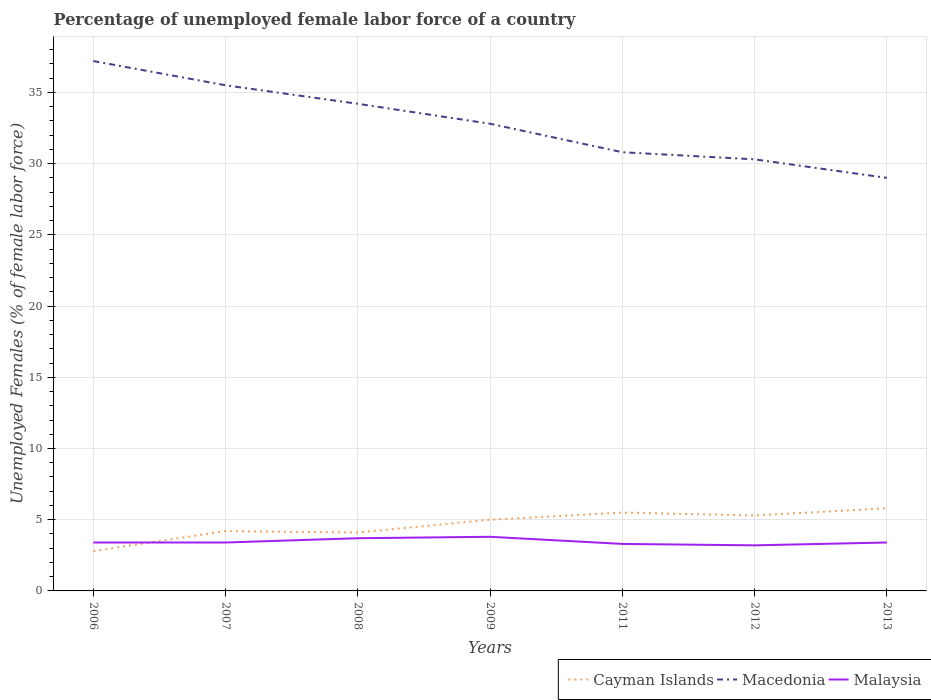How many different coloured lines are there?
Ensure brevity in your answer.  3. Is the number of lines equal to the number of legend labels?
Keep it short and to the point. Yes. Across all years, what is the maximum percentage of unemployed female labor force in Malaysia?
Provide a short and direct response. 3.2. What is the total percentage of unemployed female labor force in Malaysia in the graph?
Make the answer very short. 0.1. What is the difference between the highest and the second highest percentage of unemployed female labor force in Macedonia?
Provide a short and direct response. 8.2. Is the percentage of unemployed female labor force in Macedonia strictly greater than the percentage of unemployed female labor force in Cayman Islands over the years?
Offer a very short reply. No. What is the difference between two consecutive major ticks on the Y-axis?
Offer a very short reply. 5. Does the graph contain any zero values?
Make the answer very short. No. Where does the legend appear in the graph?
Offer a very short reply. Bottom right. How many legend labels are there?
Offer a very short reply. 3. What is the title of the graph?
Offer a terse response. Percentage of unemployed female labor force of a country. Does "Haiti" appear as one of the legend labels in the graph?
Make the answer very short. No. What is the label or title of the Y-axis?
Make the answer very short. Unemployed Females (% of female labor force). What is the Unemployed Females (% of female labor force) in Cayman Islands in 2006?
Ensure brevity in your answer.  2.8. What is the Unemployed Females (% of female labor force) of Macedonia in 2006?
Provide a succinct answer. 37.2. What is the Unemployed Females (% of female labor force) in Malaysia in 2006?
Offer a terse response. 3.4. What is the Unemployed Females (% of female labor force) of Cayman Islands in 2007?
Provide a succinct answer. 4.2. What is the Unemployed Females (% of female labor force) of Macedonia in 2007?
Provide a succinct answer. 35.5. What is the Unemployed Females (% of female labor force) in Malaysia in 2007?
Keep it short and to the point. 3.4. What is the Unemployed Females (% of female labor force) of Cayman Islands in 2008?
Keep it short and to the point. 4.1. What is the Unemployed Females (% of female labor force) of Macedonia in 2008?
Your response must be concise. 34.2. What is the Unemployed Females (% of female labor force) in Malaysia in 2008?
Make the answer very short. 3.7. What is the Unemployed Females (% of female labor force) in Cayman Islands in 2009?
Make the answer very short. 5. What is the Unemployed Females (% of female labor force) of Macedonia in 2009?
Provide a short and direct response. 32.8. What is the Unemployed Females (% of female labor force) of Malaysia in 2009?
Your answer should be compact. 3.8. What is the Unemployed Females (% of female labor force) of Cayman Islands in 2011?
Keep it short and to the point. 5.5. What is the Unemployed Females (% of female labor force) in Macedonia in 2011?
Your response must be concise. 30.8. What is the Unemployed Females (% of female labor force) of Malaysia in 2011?
Give a very brief answer. 3.3. What is the Unemployed Females (% of female labor force) of Cayman Islands in 2012?
Your answer should be compact. 5.3. What is the Unemployed Females (% of female labor force) of Macedonia in 2012?
Provide a succinct answer. 30.3. What is the Unemployed Females (% of female labor force) of Malaysia in 2012?
Keep it short and to the point. 3.2. What is the Unemployed Females (% of female labor force) of Cayman Islands in 2013?
Provide a succinct answer. 5.8. What is the Unemployed Females (% of female labor force) of Malaysia in 2013?
Make the answer very short. 3.4. Across all years, what is the maximum Unemployed Females (% of female labor force) of Cayman Islands?
Ensure brevity in your answer.  5.8. Across all years, what is the maximum Unemployed Females (% of female labor force) in Macedonia?
Your response must be concise. 37.2. Across all years, what is the maximum Unemployed Females (% of female labor force) in Malaysia?
Offer a terse response. 3.8. Across all years, what is the minimum Unemployed Females (% of female labor force) in Cayman Islands?
Your answer should be compact. 2.8. Across all years, what is the minimum Unemployed Females (% of female labor force) of Malaysia?
Your response must be concise. 3.2. What is the total Unemployed Females (% of female labor force) in Cayman Islands in the graph?
Keep it short and to the point. 32.7. What is the total Unemployed Females (% of female labor force) in Macedonia in the graph?
Provide a short and direct response. 229.8. What is the total Unemployed Females (% of female labor force) in Malaysia in the graph?
Keep it short and to the point. 24.2. What is the difference between the Unemployed Females (% of female labor force) in Malaysia in 2006 and that in 2007?
Ensure brevity in your answer.  0. What is the difference between the Unemployed Females (% of female labor force) of Macedonia in 2006 and that in 2008?
Your answer should be very brief. 3. What is the difference between the Unemployed Females (% of female labor force) of Macedonia in 2006 and that in 2011?
Your answer should be very brief. 6.4. What is the difference between the Unemployed Females (% of female labor force) of Cayman Islands in 2006 and that in 2012?
Ensure brevity in your answer.  -2.5. What is the difference between the Unemployed Females (% of female labor force) in Malaysia in 2006 and that in 2012?
Give a very brief answer. 0.2. What is the difference between the Unemployed Females (% of female labor force) of Cayman Islands in 2006 and that in 2013?
Make the answer very short. -3. What is the difference between the Unemployed Females (% of female labor force) of Malaysia in 2006 and that in 2013?
Your answer should be very brief. 0. What is the difference between the Unemployed Females (% of female labor force) of Macedonia in 2007 and that in 2008?
Ensure brevity in your answer.  1.3. What is the difference between the Unemployed Females (% of female labor force) in Malaysia in 2007 and that in 2008?
Your response must be concise. -0.3. What is the difference between the Unemployed Females (% of female labor force) in Malaysia in 2007 and that in 2011?
Offer a terse response. 0.1. What is the difference between the Unemployed Females (% of female labor force) in Macedonia in 2007 and that in 2012?
Your answer should be very brief. 5.2. What is the difference between the Unemployed Females (% of female labor force) in Malaysia in 2007 and that in 2012?
Make the answer very short. 0.2. What is the difference between the Unemployed Females (% of female labor force) in Macedonia in 2007 and that in 2013?
Your answer should be very brief. 6.5. What is the difference between the Unemployed Females (% of female labor force) of Malaysia in 2007 and that in 2013?
Provide a short and direct response. 0. What is the difference between the Unemployed Females (% of female labor force) of Malaysia in 2008 and that in 2009?
Give a very brief answer. -0.1. What is the difference between the Unemployed Females (% of female labor force) of Malaysia in 2008 and that in 2011?
Your answer should be very brief. 0.4. What is the difference between the Unemployed Females (% of female labor force) of Cayman Islands in 2008 and that in 2012?
Ensure brevity in your answer.  -1.2. What is the difference between the Unemployed Females (% of female labor force) in Malaysia in 2008 and that in 2012?
Provide a succinct answer. 0.5. What is the difference between the Unemployed Females (% of female labor force) in Macedonia in 2008 and that in 2013?
Make the answer very short. 5.2. What is the difference between the Unemployed Females (% of female labor force) in Cayman Islands in 2009 and that in 2011?
Offer a terse response. -0.5. What is the difference between the Unemployed Females (% of female labor force) of Malaysia in 2009 and that in 2011?
Provide a short and direct response. 0.5. What is the difference between the Unemployed Females (% of female labor force) in Macedonia in 2009 and that in 2012?
Make the answer very short. 2.5. What is the difference between the Unemployed Females (% of female labor force) of Malaysia in 2009 and that in 2013?
Provide a short and direct response. 0.4. What is the difference between the Unemployed Females (% of female labor force) of Malaysia in 2011 and that in 2012?
Your answer should be compact. 0.1. What is the difference between the Unemployed Females (% of female labor force) of Cayman Islands in 2011 and that in 2013?
Give a very brief answer. -0.3. What is the difference between the Unemployed Females (% of female labor force) of Macedonia in 2012 and that in 2013?
Provide a short and direct response. 1.3. What is the difference between the Unemployed Females (% of female labor force) of Malaysia in 2012 and that in 2013?
Offer a very short reply. -0.2. What is the difference between the Unemployed Females (% of female labor force) in Cayman Islands in 2006 and the Unemployed Females (% of female labor force) in Macedonia in 2007?
Provide a succinct answer. -32.7. What is the difference between the Unemployed Females (% of female labor force) in Macedonia in 2006 and the Unemployed Females (% of female labor force) in Malaysia in 2007?
Keep it short and to the point. 33.8. What is the difference between the Unemployed Females (% of female labor force) in Cayman Islands in 2006 and the Unemployed Females (% of female labor force) in Macedonia in 2008?
Offer a terse response. -31.4. What is the difference between the Unemployed Females (% of female labor force) in Macedonia in 2006 and the Unemployed Females (% of female labor force) in Malaysia in 2008?
Your answer should be very brief. 33.5. What is the difference between the Unemployed Females (% of female labor force) in Macedonia in 2006 and the Unemployed Females (% of female labor force) in Malaysia in 2009?
Your answer should be compact. 33.4. What is the difference between the Unemployed Females (% of female labor force) of Cayman Islands in 2006 and the Unemployed Females (% of female labor force) of Macedonia in 2011?
Offer a very short reply. -28. What is the difference between the Unemployed Females (% of female labor force) in Cayman Islands in 2006 and the Unemployed Females (% of female labor force) in Malaysia in 2011?
Offer a terse response. -0.5. What is the difference between the Unemployed Females (% of female labor force) of Macedonia in 2006 and the Unemployed Females (% of female labor force) of Malaysia in 2011?
Your response must be concise. 33.9. What is the difference between the Unemployed Females (% of female labor force) of Cayman Islands in 2006 and the Unemployed Females (% of female labor force) of Macedonia in 2012?
Your response must be concise. -27.5. What is the difference between the Unemployed Females (% of female labor force) of Cayman Islands in 2006 and the Unemployed Females (% of female labor force) of Malaysia in 2012?
Give a very brief answer. -0.4. What is the difference between the Unemployed Females (% of female labor force) in Macedonia in 2006 and the Unemployed Females (% of female labor force) in Malaysia in 2012?
Offer a terse response. 34. What is the difference between the Unemployed Females (% of female labor force) in Cayman Islands in 2006 and the Unemployed Females (% of female labor force) in Macedonia in 2013?
Give a very brief answer. -26.2. What is the difference between the Unemployed Females (% of female labor force) of Macedonia in 2006 and the Unemployed Females (% of female labor force) of Malaysia in 2013?
Your answer should be compact. 33.8. What is the difference between the Unemployed Females (% of female labor force) of Cayman Islands in 2007 and the Unemployed Females (% of female labor force) of Malaysia in 2008?
Offer a terse response. 0.5. What is the difference between the Unemployed Females (% of female labor force) of Macedonia in 2007 and the Unemployed Females (% of female labor force) of Malaysia in 2008?
Your answer should be compact. 31.8. What is the difference between the Unemployed Females (% of female labor force) of Cayman Islands in 2007 and the Unemployed Females (% of female labor force) of Macedonia in 2009?
Provide a succinct answer. -28.6. What is the difference between the Unemployed Females (% of female labor force) of Macedonia in 2007 and the Unemployed Females (% of female labor force) of Malaysia in 2009?
Make the answer very short. 31.7. What is the difference between the Unemployed Females (% of female labor force) of Cayman Islands in 2007 and the Unemployed Females (% of female labor force) of Macedonia in 2011?
Give a very brief answer. -26.6. What is the difference between the Unemployed Females (% of female labor force) in Macedonia in 2007 and the Unemployed Females (% of female labor force) in Malaysia in 2011?
Your answer should be compact. 32.2. What is the difference between the Unemployed Females (% of female labor force) of Cayman Islands in 2007 and the Unemployed Females (% of female labor force) of Macedonia in 2012?
Make the answer very short. -26.1. What is the difference between the Unemployed Females (% of female labor force) in Cayman Islands in 2007 and the Unemployed Females (% of female labor force) in Malaysia in 2012?
Provide a succinct answer. 1. What is the difference between the Unemployed Females (% of female labor force) in Macedonia in 2007 and the Unemployed Females (% of female labor force) in Malaysia in 2012?
Give a very brief answer. 32.3. What is the difference between the Unemployed Females (% of female labor force) of Cayman Islands in 2007 and the Unemployed Females (% of female labor force) of Macedonia in 2013?
Your answer should be very brief. -24.8. What is the difference between the Unemployed Females (% of female labor force) in Cayman Islands in 2007 and the Unemployed Females (% of female labor force) in Malaysia in 2013?
Give a very brief answer. 0.8. What is the difference between the Unemployed Females (% of female labor force) of Macedonia in 2007 and the Unemployed Females (% of female labor force) of Malaysia in 2013?
Offer a very short reply. 32.1. What is the difference between the Unemployed Females (% of female labor force) in Cayman Islands in 2008 and the Unemployed Females (% of female labor force) in Macedonia in 2009?
Provide a succinct answer. -28.7. What is the difference between the Unemployed Females (% of female labor force) of Cayman Islands in 2008 and the Unemployed Females (% of female labor force) of Malaysia in 2009?
Keep it short and to the point. 0.3. What is the difference between the Unemployed Females (% of female labor force) in Macedonia in 2008 and the Unemployed Females (% of female labor force) in Malaysia in 2009?
Keep it short and to the point. 30.4. What is the difference between the Unemployed Females (% of female labor force) in Cayman Islands in 2008 and the Unemployed Females (% of female labor force) in Macedonia in 2011?
Make the answer very short. -26.7. What is the difference between the Unemployed Females (% of female labor force) in Macedonia in 2008 and the Unemployed Females (% of female labor force) in Malaysia in 2011?
Provide a succinct answer. 30.9. What is the difference between the Unemployed Females (% of female labor force) in Cayman Islands in 2008 and the Unemployed Females (% of female labor force) in Macedonia in 2012?
Your answer should be compact. -26.2. What is the difference between the Unemployed Females (% of female labor force) in Cayman Islands in 2008 and the Unemployed Females (% of female labor force) in Malaysia in 2012?
Provide a succinct answer. 0.9. What is the difference between the Unemployed Females (% of female labor force) of Cayman Islands in 2008 and the Unemployed Females (% of female labor force) of Macedonia in 2013?
Your answer should be compact. -24.9. What is the difference between the Unemployed Females (% of female labor force) in Macedonia in 2008 and the Unemployed Females (% of female labor force) in Malaysia in 2013?
Provide a short and direct response. 30.8. What is the difference between the Unemployed Females (% of female labor force) in Cayman Islands in 2009 and the Unemployed Females (% of female labor force) in Macedonia in 2011?
Offer a terse response. -25.8. What is the difference between the Unemployed Females (% of female labor force) in Cayman Islands in 2009 and the Unemployed Females (% of female labor force) in Malaysia in 2011?
Offer a terse response. 1.7. What is the difference between the Unemployed Females (% of female labor force) of Macedonia in 2009 and the Unemployed Females (% of female labor force) of Malaysia in 2011?
Ensure brevity in your answer.  29.5. What is the difference between the Unemployed Females (% of female labor force) of Cayman Islands in 2009 and the Unemployed Females (% of female labor force) of Macedonia in 2012?
Offer a very short reply. -25.3. What is the difference between the Unemployed Females (% of female labor force) in Macedonia in 2009 and the Unemployed Females (% of female labor force) in Malaysia in 2012?
Offer a very short reply. 29.6. What is the difference between the Unemployed Females (% of female labor force) in Cayman Islands in 2009 and the Unemployed Females (% of female labor force) in Macedonia in 2013?
Your response must be concise. -24. What is the difference between the Unemployed Females (% of female labor force) in Macedonia in 2009 and the Unemployed Females (% of female labor force) in Malaysia in 2013?
Keep it short and to the point. 29.4. What is the difference between the Unemployed Females (% of female labor force) in Cayman Islands in 2011 and the Unemployed Females (% of female labor force) in Macedonia in 2012?
Offer a terse response. -24.8. What is the difference between the Unemployed Females (% of female labor force) in Macedonia in 2011 and the Unemployed Females (% of female labor force) in Malaysia in 2012?
Give a very brief answer. 27.6. What is the difference between the Unemployed Females (% of female labor force) of Cayman Islands in 2011 and the Unemployed Females (% of female labor force) of Macedonia in 2013?
Make the answer very short. -23.5. What is the difference between the Unemployed Females (% of female labor force) of Macedonia in 2011 and the Unemployed Females (% of female labor force) of Malaysia in 2013?
Provide a short and direct response. 27.4. What is the difference between the Unemployed Females (% of female labor force) in Cayman Islands in 2012 and the Unemployed Females (% of female labor force) in Macedonia in 2013?
Keep it short and to the point. -23.7. What is the difference between the Unemployed Females (% of female labor force) in Cayman Islands in 2012 and the Unemployed Females (% of female labor force) in Malaysia in 2013?
Ensure brevity in your answer.  1.9. What is the difference between the Unemployed Females (% of female labor force) in Macedonia in 2012 and the Unemployed Females (% of female labor force) in Malaysia in 2013?
Make the answer very short. 26.9. What is the average Unemployed Females (% of female labor force) in Cayman Islands per year?
Provide a short and direct response. 4.67. What is the average Unemployed Females (% of female labor force) of Macedonia per year?
Offer a terse response. 32.83. What is the average Unemployed Females (% of female labor force) in Malaysia per year?
Keep it short and to the point. 3.46. In the year 2006, what is the difference between the Unemployed Females (% of female labor force) of Cayman Islands and Unemployed Females (% of female labor force) of Macedonia?
Your answer should be very brief. -34.4. In the year 2006, what is the difference between the Unemployed Females (% of female labor force) in Macedonia and Unemployed Females (% of female labor force) in Malaysia?
Your answer should be compact. 33.8. In the year 2007, what is the difference between the Unemployed Females (% of female labor force) of Cayman Islands and Unemployed Females (% of female labor force) of Macedonia?
Your response must be concise. -31.3. In the year 2007, what is the difference between the Unemployed Females (% of female labor force) of Macedonia and Unemployed Females (% of female labor force) of Malaysia?
Offer a terse response. 32.1. In the year 2008, what is the difference between the Unemployed Females (% of female labor force) of Cayman Islands and Unemployed Females (% of female labor force) of Macedonia?
Provide a succinct answer. -30.1. In the year 2008, what is the difference between the Unemployed Females (% of female labor force) in Macedonia and Unemployed Females (% of female labor force) in Malaysia?
Your response must be concise. 30.5. In the year 2009, what is the difference between the Unemployed Females (% of female labor force) of Cayman Islands and Unemployed Females (% of female labor force) of Macedonia?
Provide a succinct answer. -27.8. In the year 2009, what is the difference between the Unemployed Females (% of female labor force) in Macedonia and Unemployed Females (% of female labor force) in Malaysia?
Provide a short and direct response. 29. In the year 2011, what is the difference between the Unemployed Females (% of female labor force) of Cayman Islands and Unemployed Females (% of female labor force) of Macedonia?
Ensure brevity in your answer.  -25.3. In the year 2011, what is the difference between the Unemployed Females (% of female labor force) in Cayman Islands and Unemployed Females (% of female labor force) in Malaysia?
Offer a very short reply. 2.2. In the year 2011, what is the difference between the Unemployed Females (% of female labor force) of Macedonia and Unemployed Females (% of female labor force) of Malaysia?
Give a very brief answer. 27.5. In the year 2012, what is the difference between the Unemployed Females (% of female labor force) of Cayman Islands and Unemployed Females (% of female labor force) of Macedonia?
Offer a terse response. -25. In the year 2012, what is the difference between the Unemployed Females (% of female labor force) of Cayman Islands and Unemployed Females (% of female labor force) of Malaysia?
Your response must be concise. 2.1. In the year 2012, what is the difference between the Unemployed Females (% of female labor force) in Macedonia and Unemployed Females (% of female labor force) in Malaysia?
Provide a short and direct response. 27.1. In the year 2013, what is the difference between the Unemployed Females (% of female labor force) in Cayman Islands and Unemployed Females (% of female labor force) in Macedonia?
Offer a terse response. -23.2. In the year 2013, what is the difference between the Unemployed Females (% of female labor force) of Cayman Islands and Unemployed Females (% of female labor force) of Malaysia?
Make the answer very short. 2.4. In the year 2013, what is the difference between the Unemployed Females (% of female labor force) of Macedonia and Unemployed Females (% of female labor force) of Malaysia?
Provide a succinct answer. 25.6. What is the ratio of the Unemployed Females (% of female labor force) of Cayman Islands in 2006 to that in 2007?
Your response must be concise. 0.67. What is the ratio of the Unemployed Females (% of female labor force) of Macedonia in 2006 to that in 2007?
Give a very brief answer. 1.05. What is the ratio of the Unemployed Females (% of female labor force) of Cayman Islands in 2006 to that in 2008?
Ensure brevity in your answer.  0.68. What is the ratio of the Unemployed Females (% of female labor force) in Macedonia in 2006 to that in 2008?
Make the answer very short. 1.09. What is the ratio of the Unemployed Females (% of female labor force) of Malaysia in 2006 to that in 2008?
Your answer should be very brief. 0.92. What is the ratio of the Unemployed Females (% of female labor force) of Cayman Islands in 2006 to that in 2009?
Your answer should be compact. 0.56. What is the ratio of the Unemployed Females (% of female labor force) in Macedonia in 2006 to that in 2009?
Keep it short and to the point. 1.13. What is the ratio of the Unemployed Females (% of female labor force) in Malaysia in 2006 to that in 2009?
Your answer should be very brief. 0.89. What is the ratio of the Unemployed Females (% of female labor force) of Cayman Islands in 2006 to that in 2011?
Offer a terse response. 0.51. What is the ratio of the Unemployed Females (% of female labor force) in Macedonia in 2006 to that in 2011?
Ensure brevity in your answer.  1.21. What is the ratio of the Unemployed Females (% of female labor force) of Malaysia in 2006 to that in 2011?
Offer a terse response. 1.03. What is the ratio of the Unemployed Females (% of female labor force) of Cayman Islands in 2006 to that in 2012?
Keep it short and to the point. 0.53. What is the ratio of the Unemployed Females (% of female labor force) of Macedonia in 2006 to that in 2012?
Make the answer very short. 1.23. What is the ratio of the Unemployed Females (% of female labor force) in Malaysia in 2006 to that in 2012?
Offer a very short reply. 1.06. What is the ratio of the Unemployed Females (% of female labor force) of Cayman Islands in 2006 to that in 2013?
Ensure brevity in your answer.  0.48. What is the ratio of the Unemployed Females (% of female labor force) of Macedonia in 2006 to that in 2013?
Provide a short and direct response. 1.28. What is the ratio of the Unemployed Females (% of female labor force) in Cayman Islands in 2007 to that in 2008?
Provide a succinct answer. 1.02. What is the ratio of the Unemployed Females (% of female labor force) in Macedonia in 2007 to that in 2008?
Provide a short and direct response. 1.04. What is the ratio of the Unemployed Females (% of female labor force) in Malaysia in 2007 to that in 2008?
Make the answer very short. 0.92. What is the ratio of the Unemployed Females (% of female labor force) in Cayman Islands in 2007 to that in 2009?
Your answer should be compact. 0.84. What is the ratio of the Unemployed Females (% of female labor force) in Macedonia in 2007 to that in 2009?
Ensure brevity in your answer.  1.08. What is the ratio of the Unemployed Females (% of female labor force) of Malaysia in 2007 to that in 2009?
Provide a short and direct response. 0.89. What is the ratio of the Unemployed Females (% of female labor force) in Cayman Islands in 2007 to that in 2011?
Keep it short and to the point. 0.76. What is the ratio of the Unemployed Females (% of female labor force) in Macedonia in 2007 to that in 2011?
Provide a short and direct response. 1.15. What is the ratio of the Unemployed Females (% of female labor force) of Malaysia in 2007 to that in 2011?
Your answer should be very brief. 1.03. What is the ratio of the Unemployed Females (% of female labor force) in Cayman Islands in 2007 to that in 2012?
Offer a terse response. 0.79. What is the ratio of the Unemployed Females (% of female labor force) of Macedonia in 2007 to that in 2012?
Give a very brief answer. 1.17. What is the ratio of the Unemployed Females (% of female labor force) of Cayman Islands in 2007 to that in 2013?
Your answer should be very brief. 0.72. What is the ratio of the Unemployed Females (% of female labor force) of Macedonia in 2007 to that in 2013?
Provide a short and direct response. 1.22. What is the ratio of the Unemployed Females (% of female labor force) in Cayman Islands in 2008 to that in 2009?
Ensure brevity in your answer.  0.82. What is the ratio of the Unemployed Females (% of female labor force) of Macedonia in 2008 to that in 2009?
Keep it short and to the point. 1.04. What is the ratio of the Unemployed Females (% of female labor force) of Malaysia in 2008 to that in 2009?
Provide a succinct answer. 0.97. What is the ratio of the Unemployed Females (% of female labor force) of Cayman Islands in 2008 to that in 2011?
Provide a short and direct response. 0.75. What is the ratio of the Unemployed Females (% of female labor force) of Macedonia in 2008 to that in 2011?
Your answer should be very brief. 1.11. What is the ratio of the Unemployed Females (% of female labor force) of Malaysia in 2008 to that in 2011?
Offer a terse response. 1.12. What is the ratio of the Unemployed Females (% of female labor force) in Cayman Islands in 2008 to that in 2012?
Make the answer very short. 0.77. What is the ratio of the Unemployed Females (% of female labor force) of Macedonia in 2008 to that in 2012?
Provide a succinct answer. 1.13. What is the ratio of the Unemployed Females (% of female labor force) in Malaysia in 2008 to that in 2012?
Ensure brevity in your answer.  1.16. What is the ratio of the Unemployed Females (% of female labor force) of Cayman Islands in 2008 to that in 2013?
Offer a terse response. 0.71. What is the ratio of the Unemployed Females (% of female labor force) in Macedonia in 2008 to that in 2013?
Ensure brevity in your answer.  1.18. What is the ratio of the Unemployed Females (% of female labor force) in Malaysia in 2008 to that in 2013?
Provide a succinct answer. 1.09. What is the ratio of the Unemployed Females (% of female labor force) of Cayman Islands in 2009 to that in 2011?
Offer a very short reply. 0.91. What is the ratio of the Unemployed Females (% of female labor force) of Macedonia in 2009 to that in 2011?
Your answer should be very brief. 1.06. What is the ratio of the Unemployed Females (% of female labor force) in Malaysia in 2009 to that in 2011?
Offer a terse response. 1.15. What is the ratio of the Unemployed Females (% of female labor force) in Cayman Islands in 2009 to that in 2012?
Your response must be concise. 0.94. What is the ratio of the Unemployed Females (% of female labor force) in Macedonia in 2009 to that in 2012?
Keep it short and to the point. 1.08. What is the ratio of the Unemployed Females (% of female labor force) of Malaysia in 2009 to that in 2012?
Your response must be concise. 1.19. What is the ratio of the Unemployed Females (% of female labor force) in Cayman Islands in 2009 to that in 2013?
Your answer should be compact. 0.86. What is the ratio of the Unemployed Females (% of female labor force) of Macedonia in 2009 to that in 2013?
Keep it short and to the point. 1.13. What is the ratio of the Unemployed Females (% of female labor force) in Malaysia in 2009 to that in 2013?
Ensure brevity in your answer.  1.12. What is the ratio of the Unemployed Females (% of female labor force) of Cayman Islands in 2011 to that in 2012?
Make the answer very short. 1.04. What is the ratio of the Unemployed Females (% of female labor force) in Macedonia in 2011 to that in 2012?
Ensure brevity in your answer.  1.02. What is the ratio of the Unemployed Females (% of female labor force) in Malaysia in 2011 to that in 2012?
Provide a short and direct response. 1.03. What is the ratio of the Unemployed Females (% of female labor force) in Cayman Islands in 2011 to that in 2013?
Provide a succinct answer. 0.95. What is the ratio of the Unemployed Females (% of female labor force) in Macedonia in 2011 to that in 2013?
Offer a very short reply. 1.06. What is the ratio of the Unemployed Females (% of female labor force) of Malaysia in 2011 to that in 2013?
Make the answer very short. 0.97. What is the ratio of the Unemployed Females (% of female labor force) of Cayman Islands in 2012 to that in 2013?
Your response must be concise. 0.91. What is the ratio of the Unemployed Females (% of female labor force) in Macedonia in 2012 to that in 2013?
Offer a very short reply. 1.04. What is the ratio of the Unemployed Females (% of female labor force) of Malaysia in 2012 to that in 2013?
Give a very brief answer. 0.94. What is the difference between the highest and the second highest Unemployed Females (% of female labor force) of Cayman Islands?
Give a very brief answer. 0.3. What is the difference between the highest and the second highest Unemployed Females (% of female labor force) of Macedonia?
Your answer should be compact. 1.7. What is the difference between the highest and the lowest Unemployed Females (% of female labor force) of Cayman Islands?
Keep it short and to the point. 3. What is the difference between the highest and the lowest Unemployed Females (% of female labor force) in Macedonia?
Provide a short and direct response. 8.2. 